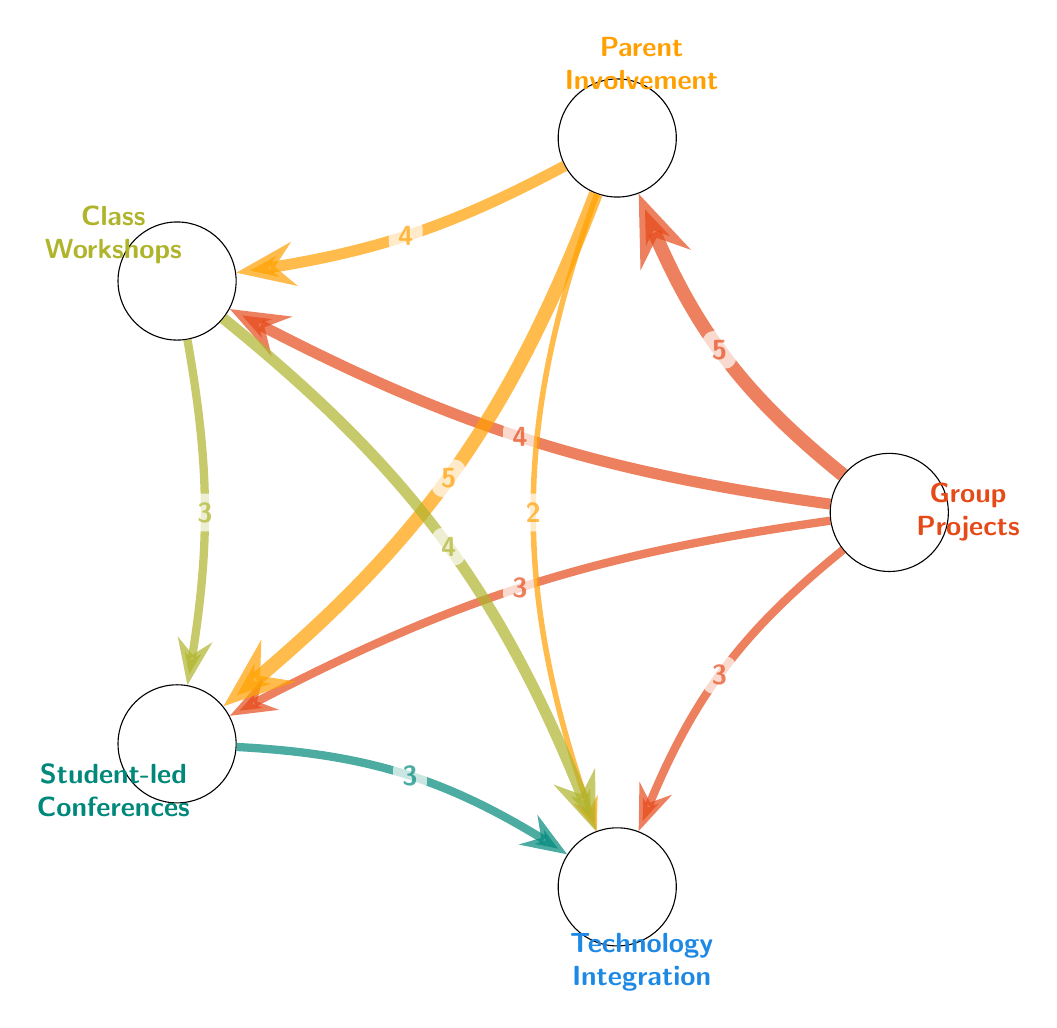What is the total number of nodes in the diagram? The diagram presents a total of five distinct nodes: Group Projects, Parent Involvement, Class Workshops, Student-led Conferences, and Technology Integration. Summing these gives a total of 5 nodes.
Answer: 5 What is the value of the link between Group Projects and Parent Involvement? The link connecting Group Projects to Parent Involvement has a value of 5, which indicates a strong association or collaboration.
Answer: 5 Which two nodes have the highest link value? The nodes Parent Involvement and Group Projects are linked with a value of 5, and this is the highest link value present in the diagram.
Answer: Parent Involvement, Group Projects How many connections does Class Workshops have? The node Class Workshops is connected to three other nodes: Group Projects, Parent Involvement, and Technology Integration. Therefore, it has a total of 3 connections.
Answer: 3 What link value connects Parent Involvement and Student-led Conferences? The link value that connects Parent Involvement and Student-led Conferences is 5, showing a significant collaborative effort between these two nodes.
Answer: 5 Which node is linked to Technology Integration with the lowest value? The lowest value link to Technology Integration is with Parent Involvement, which has a link value of 2, indicating a weaker connection compared to others.
Answer: Parent Involvement If Group Projects were removed from the diagram, which node would have the most connections left? If Group Projects is removed, the node Parent Involvement would still have connections to Class Workshops, Student-led Conferences, and Technology Integration, totaling 3 connections, making it the node with the most remaining connections.
Answer: Parent Involvement How many links are there in total? By counting all the directed links in the diagram, we find there are a total of 10 links connecting the various nodes.
Answer: 10 